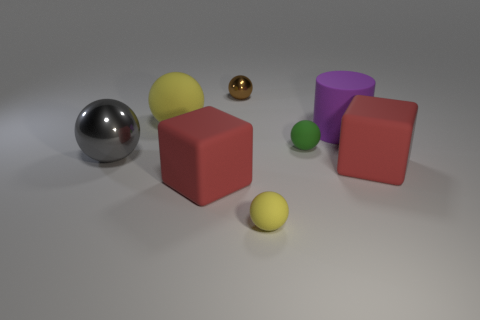How many objects are either small green matte cylinders or large red matte objects?
Provide a short and direct response. 2. Does the yellow sphere behind the green rubber ball have the same material as the large object that is to the right of the purple matte object?
Give a very brief answer. Yes. The other ball that is made of the same material as the gray sphere is what color?
Ensure brevity in your answer.  Brown. What number of blocks have the same size as the green rubber ball?
Your answer should be compact. 0. How many other objects are there of the same color as the cylinder?
Keep it short and to the point. 0. Is there any other thing that has the same size as the green thing?
Your answer should be compact. Yes. Does the shiny object in front of the small green matte object have the same shape as the tiny thing left of the tiny yellow matte ball?
Give a very brief answer. Yes. The yellow rubber thing that is the same size as the green rubber thing is what shape?
Give a very brief answer. Sphere. Are there the same number of big yellow things that are in front of the large yellow matte sphere and gray things right of the tiny shiny thing?
Your response must be concise. Yes. Are there any other things that are the same shape as the big purple object?
Your response must be concise. No. 